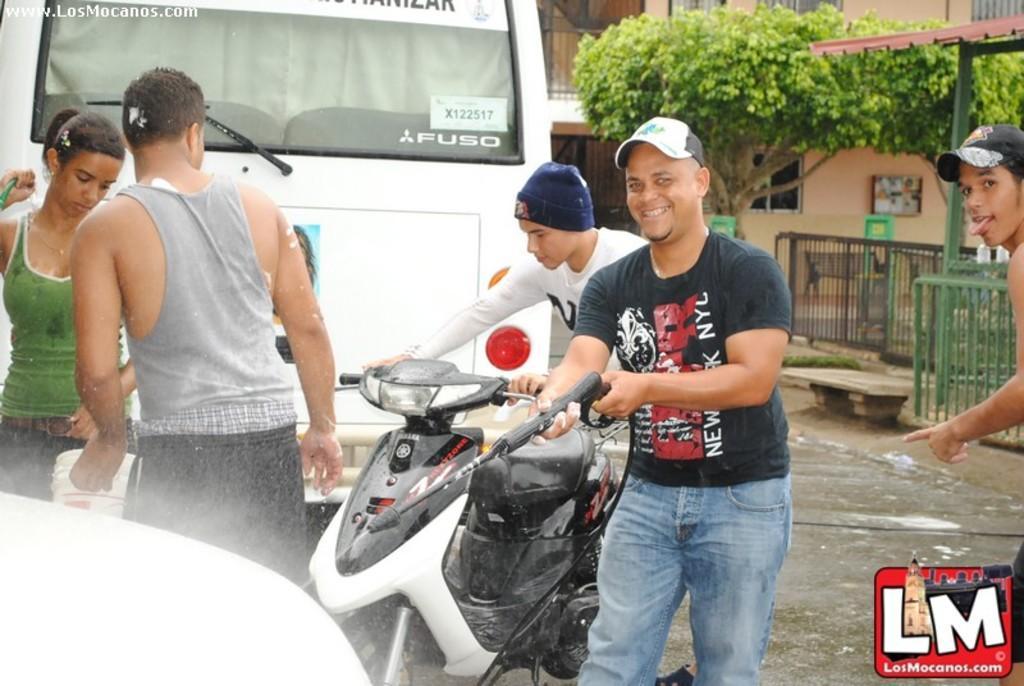Please provide a concise description of this image. On the left there is an object and a man is water on it by holding a pipe in his hands and behind him a man is holding a bike in his hands and on the left a woman is holding a pipe in her hand and a man is holding a bucket and on the right there is a man. In the background there is a vehicle,trees,fences,board on the wall and windows. 